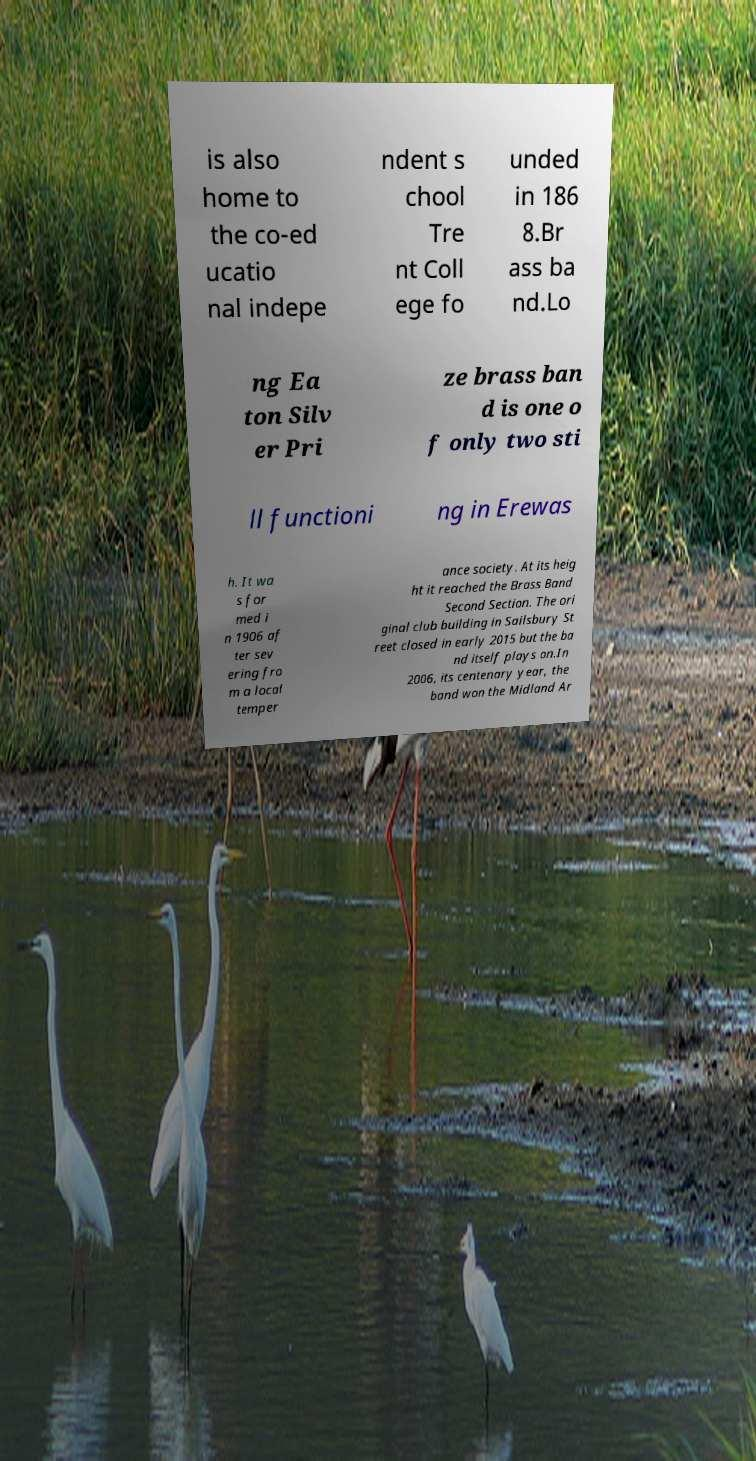Could you assist in decoding the text presented in this image and type it out clearly? is also home to the co-ed ucatio nal indepe ndent s chool Tre nt Coll ege fo unded in 186 8.Br ass ba nd.Lo ng Ea ton Silv er Pri ze brass ban d is one o f only two sti ll functioni ng in Erewas h. It wa s for med i n 1906 af ter sev ering fro m a local temper ance society. At its heig ht it reached the Brass Band Second Section. The ori ginal club building in Sailsbury St reet closed in early 2015 but the ba nd itself plays on.In 2006, its centenary year, the band won the Midland Ar 